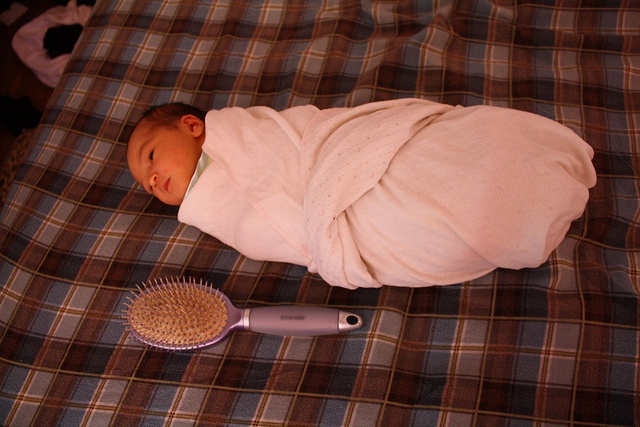Describe the objects in this image and their specific colors. I can see bed in black, maroon, and brown tones and people in black, lightpink, salmon, and maroon tones in this image. 